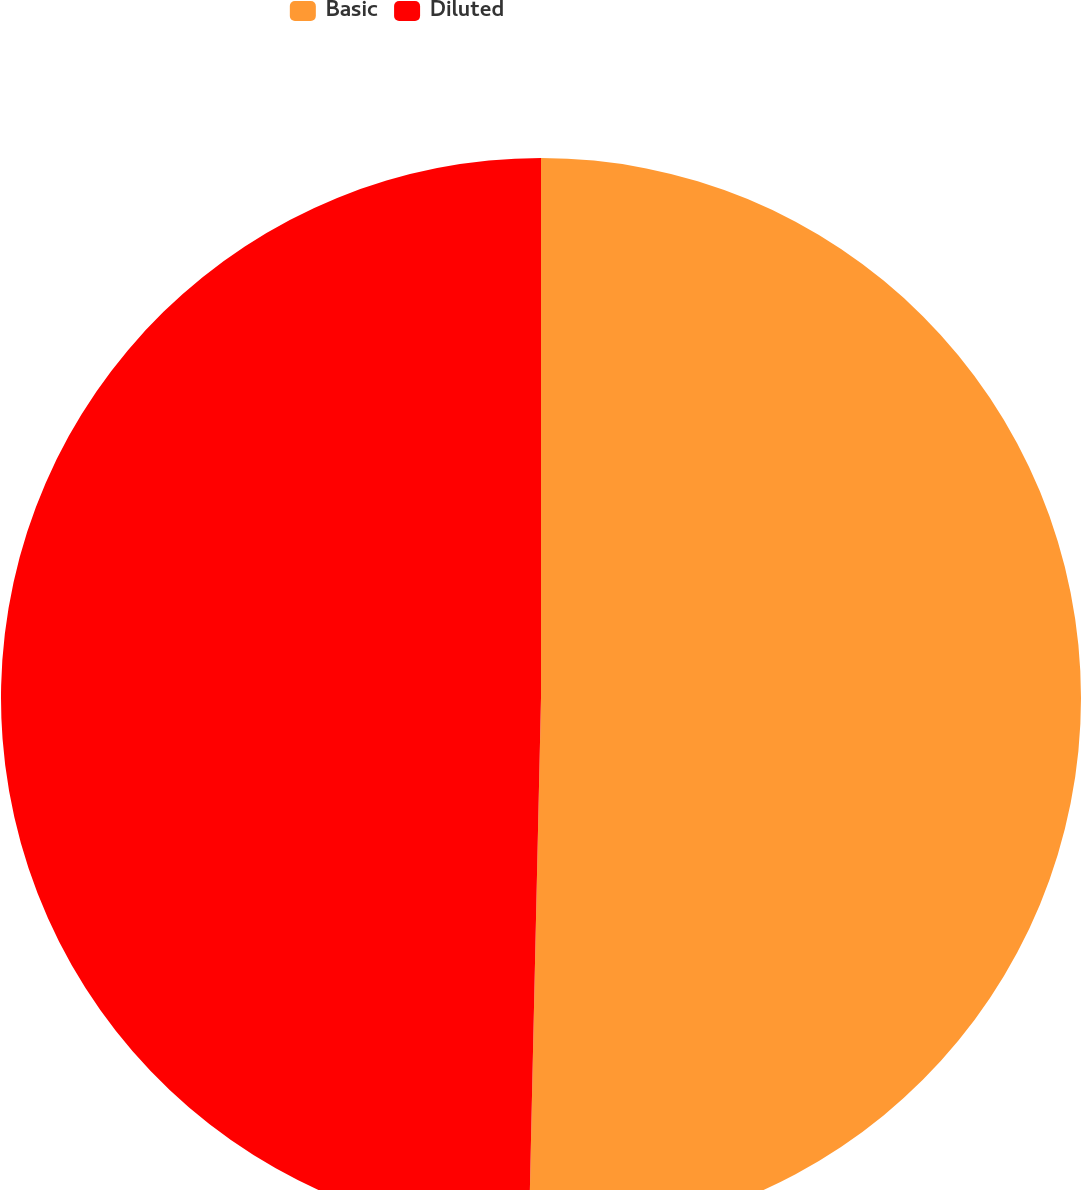Convert chart to OTSL. <chart><loc_0><loc_0><loc_500><loc_500><pie_chart><fcel>Basic<fcel>Diluted<nl><fcel>50.36%<fcel>49.64%<nl></chart> 